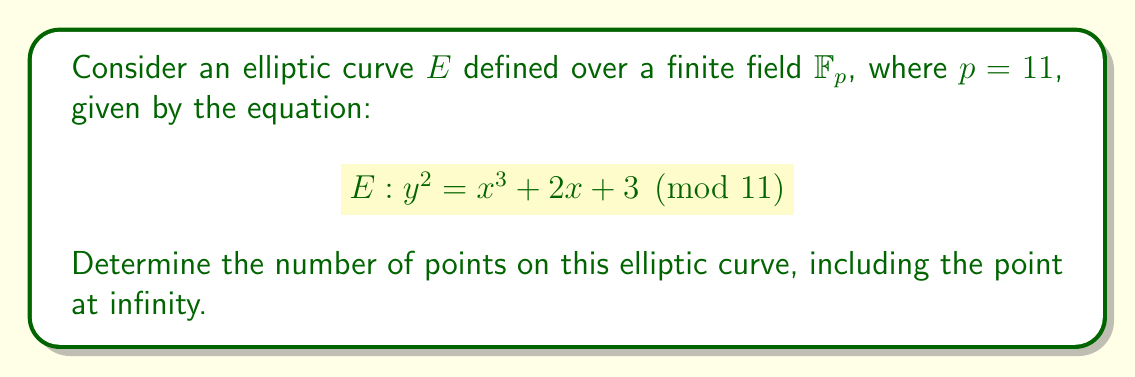Can you solve this math problem? To find the number of points on the elliptic curve, we need to follow these steps:

1) First, we need to check for which $x$ values in $\mathbb{F}_{11} = \{0, 1, 2, ..., 10\}$ the right-hand side of the equation is a quadratic residue modulo 11.

2) For each $x$, compute $x^3 + 2x + 3 \pmod{11}$:

   For $x = 0$: $0^3 + 2(0) + 3 \equiv 3 \pmod{11}$
   For $x = 1$: $1^3 + 2(1) + 3 \equiv 6 \pmod{11}$
   For $x = 2$: $2^3 + 2(2) + 3 \equiv 4 \pmod{11}$
   For $x = 3$: $3^3 + 2(3) + 3 \equiv 9 \pmod{11}$
   For $x = 4$: $4^3 + 2(4) + 3 \equiv 8 \pmod{11}$
   For $x = 5$: $5^3 + 2(5) + 3 \equiv 2 \pmod{11}$
   For $x = 6$: $6^3 + 2(6) + 3 \equiv 10 \pmod{11}$
   For $x = 7$: $7^3 + 2(7) + 3 \equiv 3 \pmod{11}$
   For $x = 8$: $8^3 + 2(8) + 3 \equiv 1 \pmod{11}$
   For $x = 9$: $9^3 + 2(9) + 3 \equiv 4 \pmod{11}$
   For $x = 10$: $10^3 + 2(10) + 3 \equiv 1 \pmod{11}$

3) Now, we need to check which of these results are quadratic residues modulo 11. The quadratic residues modulo 11 are $\{0, 1, 3, 4, 5, 9\}$.

4) Counting the points:
   - For $x = 0$, we get 3, which has 2 square roots.
   - For $x = 2$, we get 4, which has 2 square roots.
   - For $x = 3$, we get 9, which has 2 square roots.
   - For $x = 7$, we get 3, which has 2 square roots.
   - For $x = 8$, we get 1, which has 2 square roots.
   - For $x = 9$, we get 4, which has 2 square roots.
   - For $x = 10$, we get 1, which has 2 square roots.

5) In total, we have $2 + 2 + 2 + 2 + 2 + 2 + 2 = 14$ points.

6) Finally, we need to add the point at infinity, which is always on the curve.

Therefore, the total number of points on the curve is $14 + 1 = 15$.
Answer: 15 points 